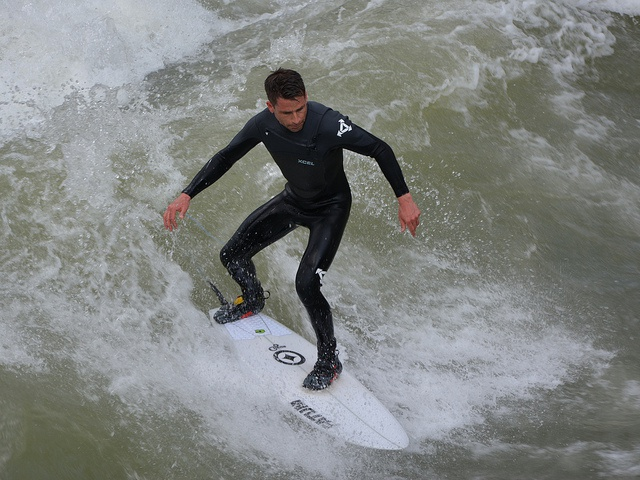Describe the objects in this image and their specific colors. I can see people in darkgray, black, gray, and brown tones and surfboard in darkgray and lightgray tones in this image. 